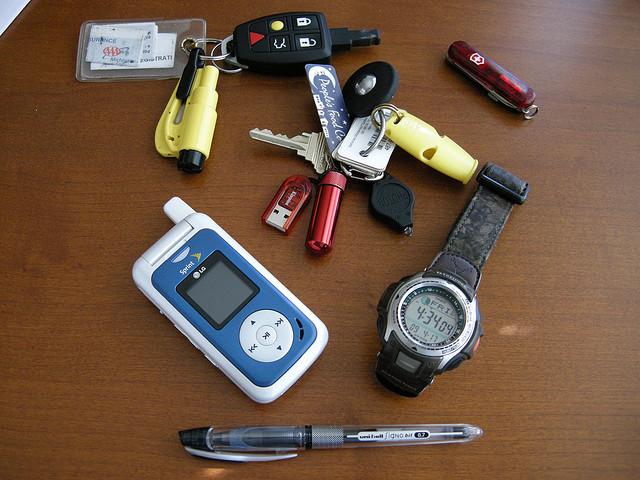What time is shown on the watch?
Keep it brief. 4:34. What brand of pen is that?
Write a very short answer. Bic. Is there a flashlight in the photo?
Answer briefly. Yes. 